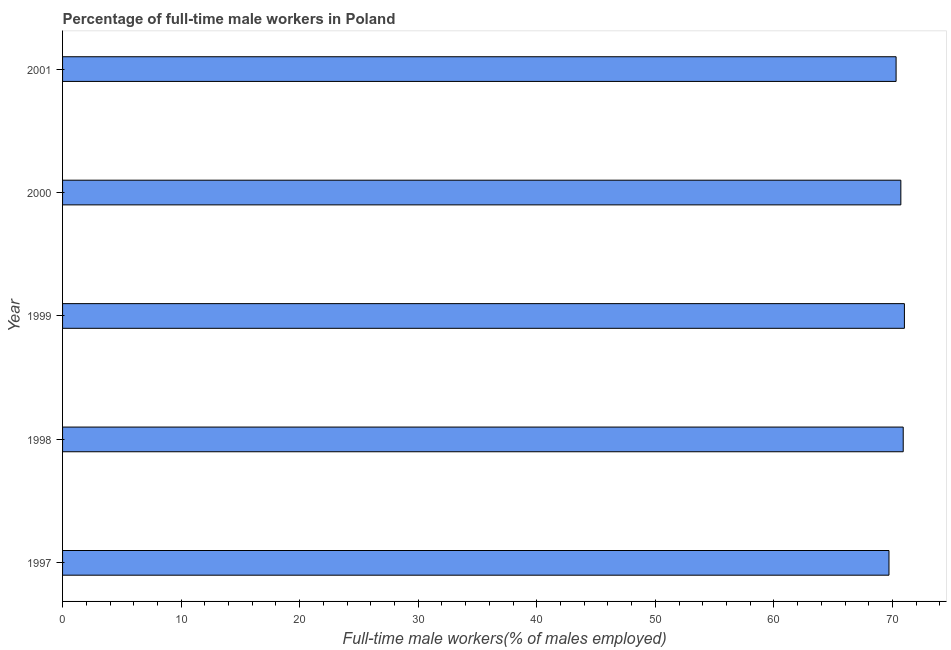What is the title of the graph?
Ensure brevity in your answer.  Percentage of full-time male workers in Poland. What is the label or title of the X-axis?
Ensure brevity in your answer.  Full-time male workers(% of males employed). What is the label or title of the Y-axis?
Your response must be concise. Year. Across all years, what is the minimum percentage of full-time male workers?
Ensure brevity in your answer.  69.7. In which year was the percentage of full-time male workers maximum?
Offer a very short reply. 1999. In which year was the percentage of full-time male workers minimum?
Your answer should be very brief. 1997. What is the sum of the percentage of full-time male workers?
Offer a very short reply. 352.6. What is the difference between the percentage of full-time male workers in 1998 and 2001?
Your answer should be very brief. 0.6. What is the average percentage of full-time male workers per year?
Offer a terse response. 70.52. What is the median percentage of full-time male workers?
Provide a succinct answer. 70.7. In how many years, is the percentage of full-time male workers greater than 60 %?
Offer a very short reply. 5. Is the percentage of full-time male workers in 1997 less than that in 1999?
Your response must be concise. Yes. What is the difference between the highest and the lowest percentage of full-time male workers?
Provide a short and direct response. 1.3. Are all the bars in the graph horizontal?
Give a very brief answer. Yes. How many years are there in the graph?
Make the answer very short. 5. What is the Full-time male workers(% of males employed) in 1997?
Your response must be concise. 69.7. What is the Full-time male workers(% of males employed) in 1998?
Ensure brevity in your answer.  70.9. What is the Full-time male workers(% of males employed) in 2000?
Offer a very short reply. 70.7. What is the Full-time male workers(% of males employed) of 2001?
Ensure brevity in your answer.  70.3. What is the difference between the Full-time male workers(% of males employed) in 1997 and 1998?
Ensure brevity in your answer.  -1.2. What is the difference between the Full-time male workers(% of males employed) in 1997 and 2001?
Keep it short and to the point. -0.6. What is the difference between the Full-time male workers(% of males employed) in 1998 and 1999?
Give a very brief answer. -0.1. What is the difference between the Full-time male workers(% of males employed) in 1998 and 2001?
Provide a succinct answer. 0.6. What is the difference between the Full-time male workers(% of males employed) in 1999 and 2000?
Offer a very short reply. 0.3. What is the difference between the Full-time male workers(% of males employed) in 1999 and 2001?
Offer a terse response. 0.7. What is the difference between the Full-time male workers(% of males employed) in 2000 and 2001?
Give a very brief answer. 0.4. What is the ratio of the Full-time male workers(% of males employed) in 1997 to that in 2000?
Offer a very short reply. 0.99. What is the ratio of the Full-time male workers(% of males employed) in 1997 to that in 2001?
Your answer should be very brief. 0.99. What is the ratio of the Full-time male workers(% of males employed) in 1998 to that in 1999?
Your response must be concise. 1. What is the ratio of the Full-time male workers(% of males employed) in 1998 to that in 2001?
Provide a succinct answer. 1.01. What is the ratio of the Full-time male workers(% of males employed) in 2000 to that in 2001?
Provide a short and direct response. 1.01. 